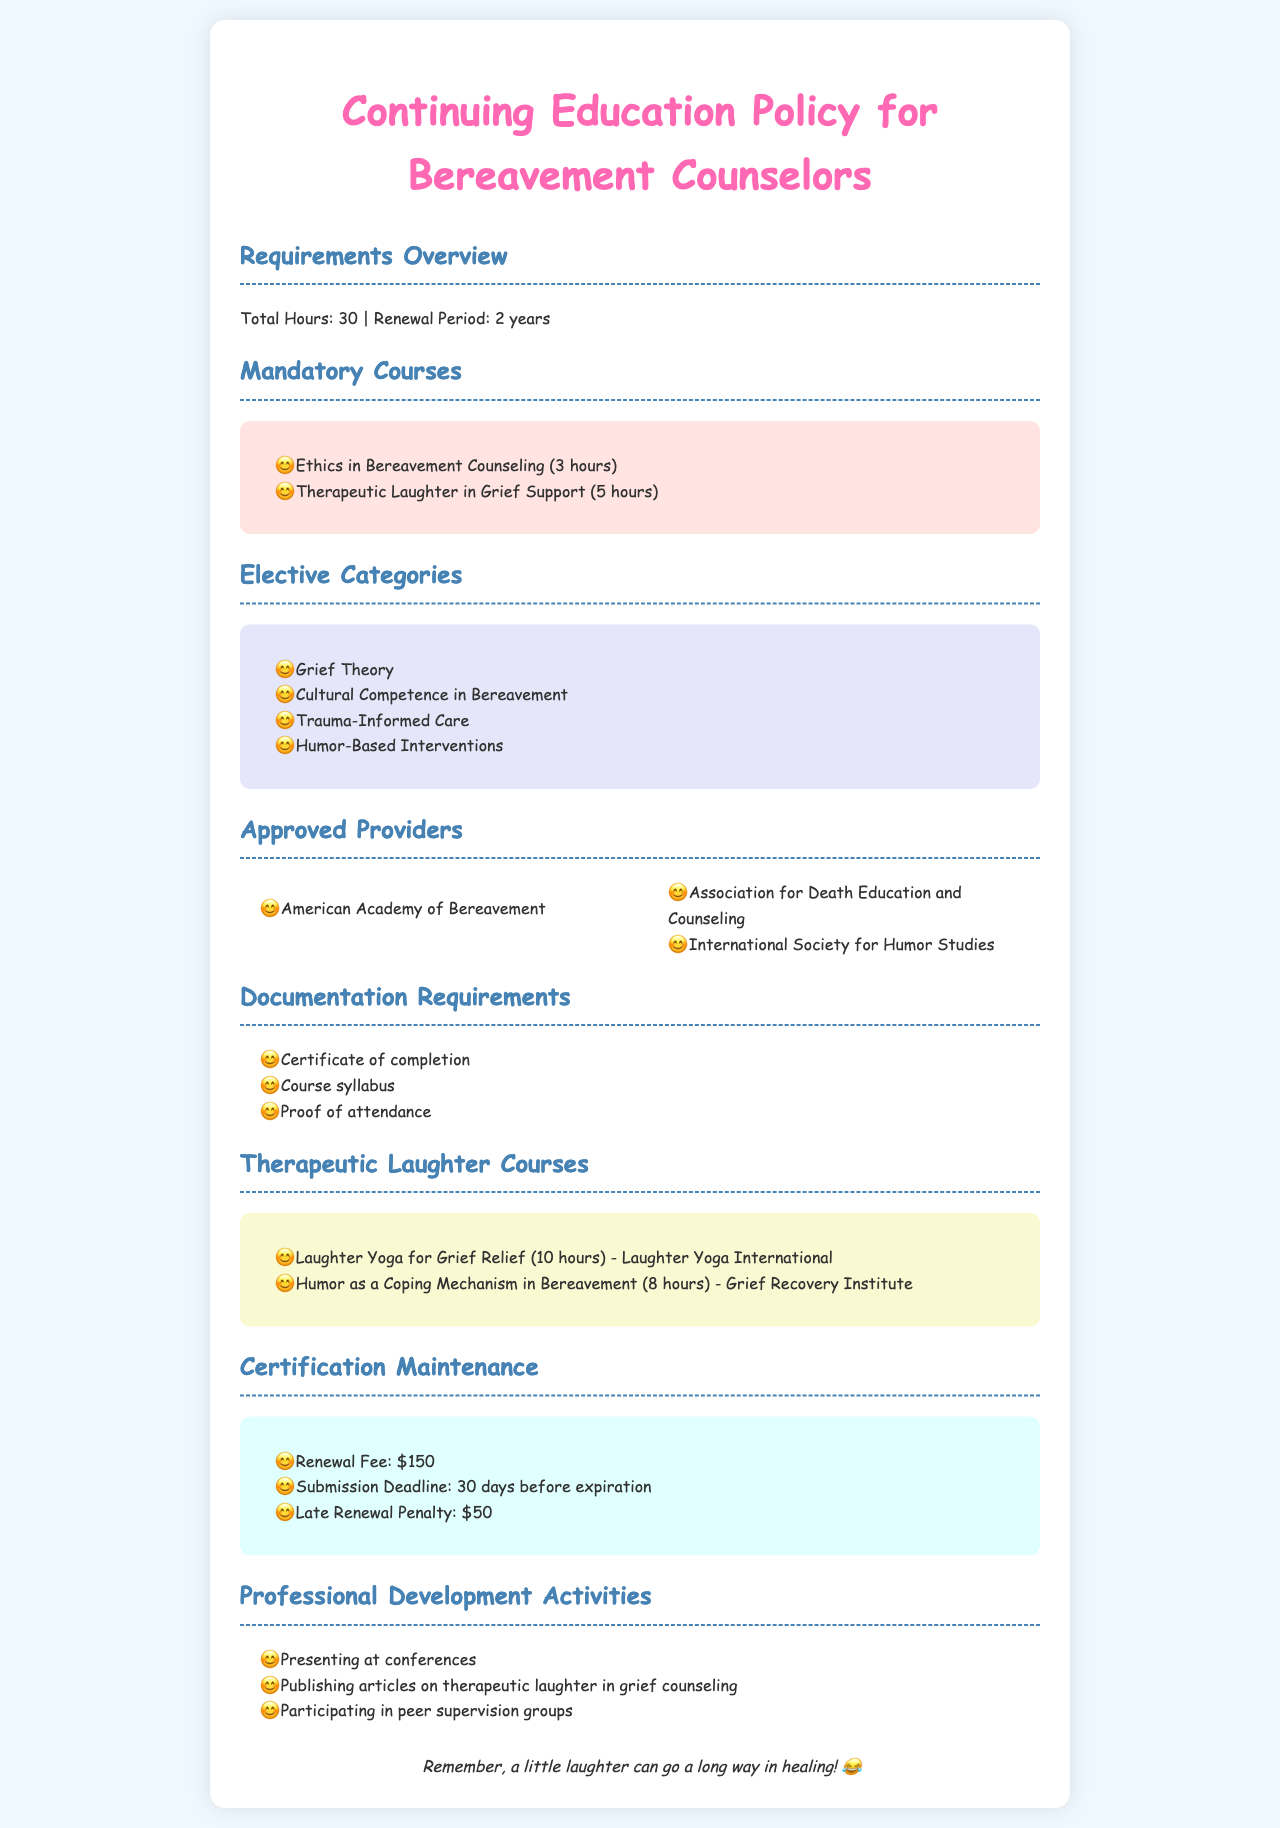What is the total number of hours required for continuing education? The total number of hours required for continuing education is stated in the requirements overview section of the document.
Answer: 30 How long is the renewal period for certification? The renewal period is specified in the requirements overview section, indicating how often counselors must renew their certification.
Answer: 2 years What is one of the mandatory courses? The document lists several mandatory courses under the mandatory courses section, focusing on what is required for continuing education.
Answer: Ethics in Bereavement Counseling How many hours is the course on Therapeutic Laughter in Grief Support? The document provides specific hours for each mandatory course, including this one, which indicates its importance in the continuing education requirements.
Answer: 5 hours Which organization is listed as an approved provider? The document includes a list of approved providers, highlighting organizations that offer eligible courses for continuing education.
Answer: American Academy of Bereavement What is the late renewal penalty fee? The certification maintenance section outlines the costs associated with maintaining certification, including penalties.
Answer: $50 What is the deadline for submission of renewal? The document contains the submission deadline information required for maintaining certification, indicating timely renewal process.
Answer: 30 days before expiration Which course is focused specifically on laughter? The document focuses on courses related to therapeutic laughter under a separate section dedicated to laughter courses.
Answer: Laughter Yoga for Grief Relief What activity qualifies as professional development? The document lists various professional development activities counselors can engage in to fulfill their certification requirements.
Answer: Presenting at conferences 